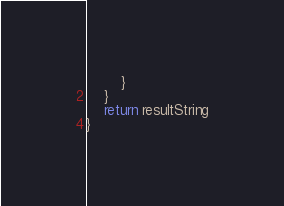Convert code to text. <code><loc_0><loc_0><loc_500><loc_500><_Kotlin_>        }
    }
    return resultString
}</code> 